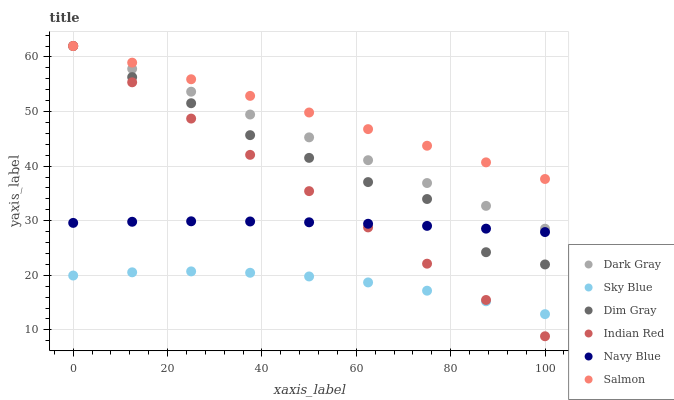Does Sky Blue have the minimum area under the curve?
Answer yes or no. Yes. Does Salmon have the maximum area under the curve?
Answer yes or no. Yes. Does Navy Blue have the minimum area under the curve?
Answer yes or no. No. Does Navy Blue have the maximum area under the curve?
Answer yes or no. No. Is Indian Red the smoothest?
Answer yes or no. Yes. Is Dim Gray the roughest?
Answer yes or no. Yes. Is Navy Blue the smoothest?
Answer yes or no. No. Is Navy Blue the roughest?
Answer yes or no. No. Does Indian Red have the lowest value?
Answer yes or no. Yes. Does Navy Blue have the lowest value?
Answer yes or no. No. Does Indian Red have the highest value?
Answer yes or no. Yes. Does Navy Blue have the highest value?
Answer yes or no. No. Is Sky Blue less than Navy Blue?
Answer yes or no. Yes. Is Salmon greater than Sky Blue?
Answer yes or no. Yes. Does Salmon intersect Dim Gray?
Answer yes or no. Yes. Is Salmon less than Dim Gray?
Answer yes or no. No. Is Salmon greater than Dim Gray?
Answer yes or no. No. Does Sky Blue intersect Navy Blue?
Answer yes or no. No. 